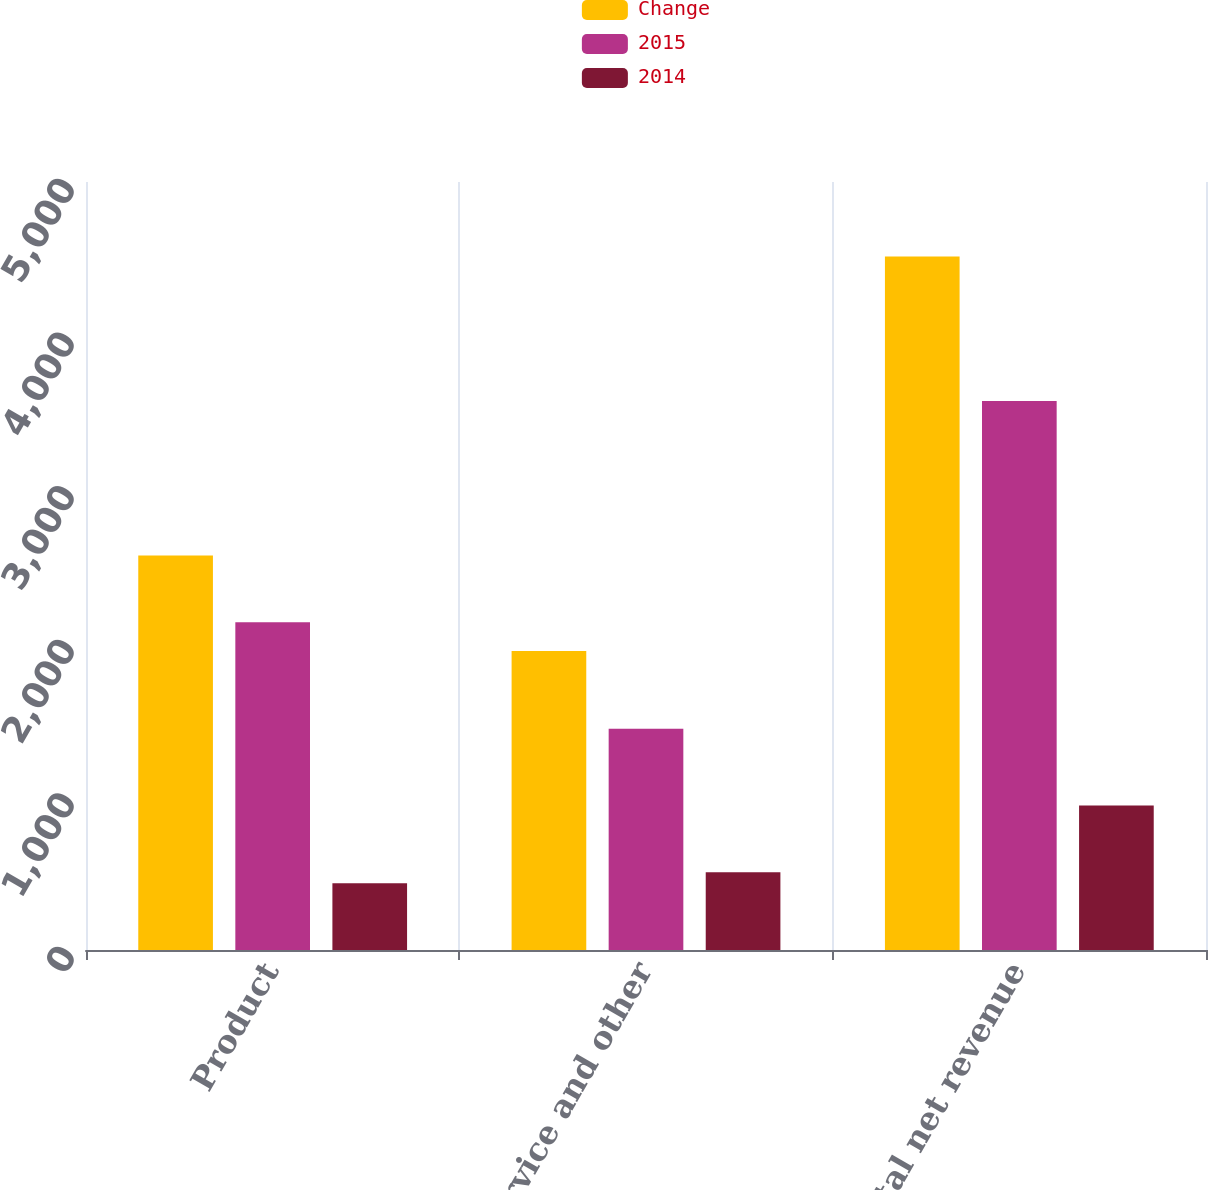Convert chart to OTSL. <chart><loc_0><loc_0><loc_500><loc_500><stacked_bar_chart><ecel><fcel>Product<fcel>Service and other<fcel>Total net revenue<nl><fcel>Change<fcel>2568<fcel>1947<fcel>4515<nl><fcel>2015<fcel>2134<fcel>1441<fcel>3575<nl><fcel>2014<fcel>434<fcel>506<fcel>940<nl></chart> 